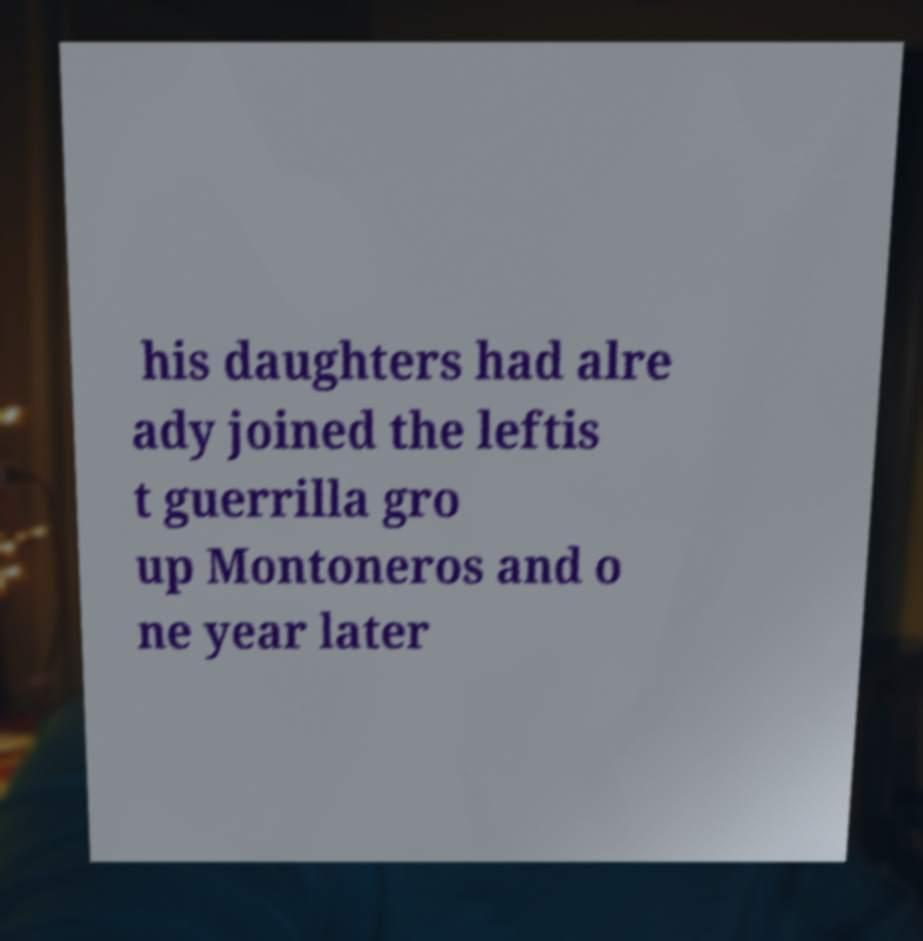I need the written content from this picture converted into text. Can you do that? his daughters had alre ady joined the leftis t guerrilla gro up Montoneros and o ne year later 